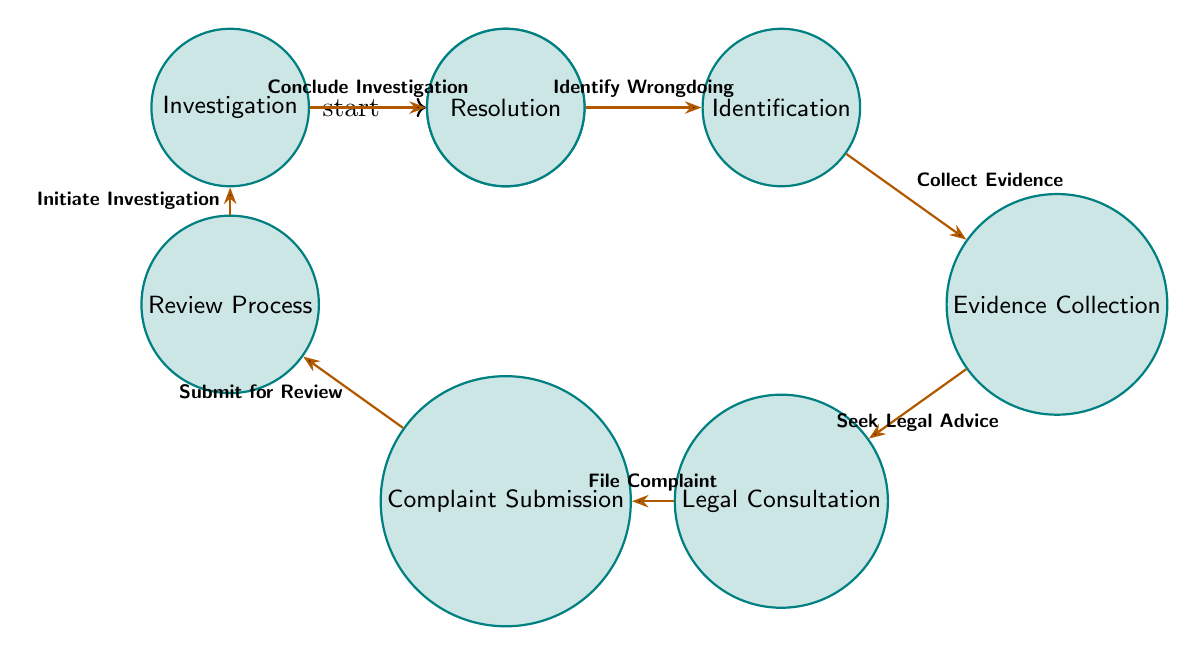What is the starting state in the diagram? The starting state is represented by the node labeled "Start." Since this is the initial point of the process, it is where all activities begin.
Answer: Start How many states are there in the diagram? The diagram lists a total of 8 states: Start, Identification, Evidence Collection, Legal Consultation, Complaint Submission, Review Process, Investigation, and Resolution.
Answer: 8 What action leads to the "Legal Consultation" state? The action that transitions to the "Legal Consultation" state is "Seek Legal Advice," which follows after the evidence has been collected.
Answer: Seek Legal Advice Which state follows "Complaint Submission"? The state that immediately follows "Complaint Submission" is "Review Process," indicating the next step after the complaint has been filed.
Answer: Review Process What is the final state in the diagram? The final state is called "Resolution," which signifies the conclusion of the entire whistleblower complaint process.
Answer: Resolution How many transitions are there in the diagram? The diagram describes 7 transitions connecting the different states, showing the process from start to resolution.
Answer: 7 What action must occur before the "Investigation" state can take place? Before reaching the "Investigation" state, the action "Initiate Investigation" must occur, which is triggered during the "Review Process."
Answer: Initiate Investigation What is the relationship between "Evidence Collection" and "Legal Consultation"? The relationship is such that "Evidence Collection" must be completed first, followed by the transition to "Legal Consultation" through the action "Seek Legal Advice."
Answer: Evidence Collection to Legal Consultation 